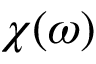<formula> <loc_0><loc_0><loc_500><loc_500>\chi ( \omega )</formula> 